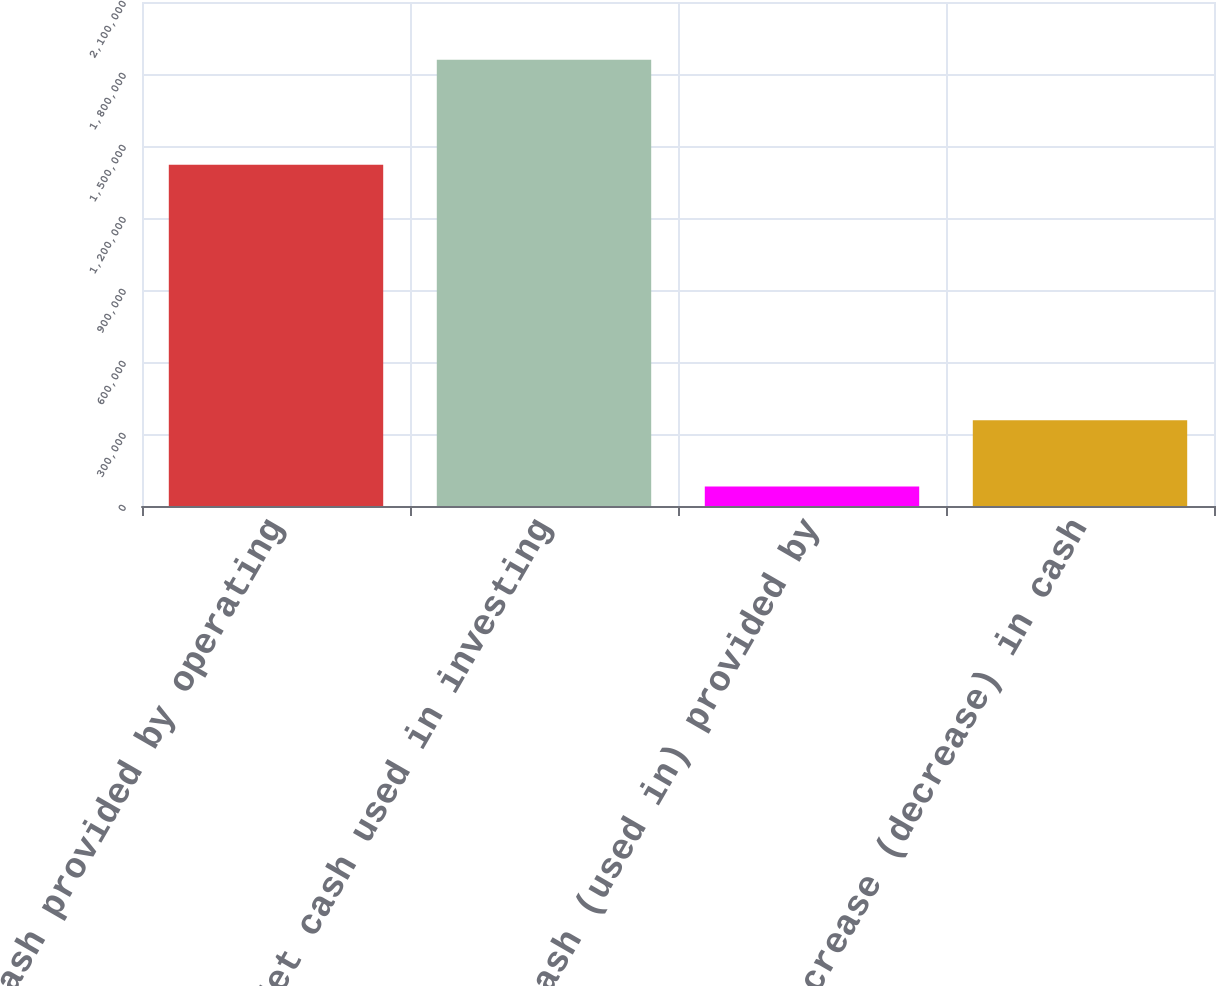<chart> <loc_0><loc_0><loc_500><loc_500><bar_chart><fcel>Net cash provided by operating<fcel>Net cash used in investing<fcel>Net cash (used in) provided by<fcel>Increase (decrease) in cash<nl><fcel>1.42158e+06<fcel>1.85926e+06<fcel>80844<fcel>356835<nl></chart> 